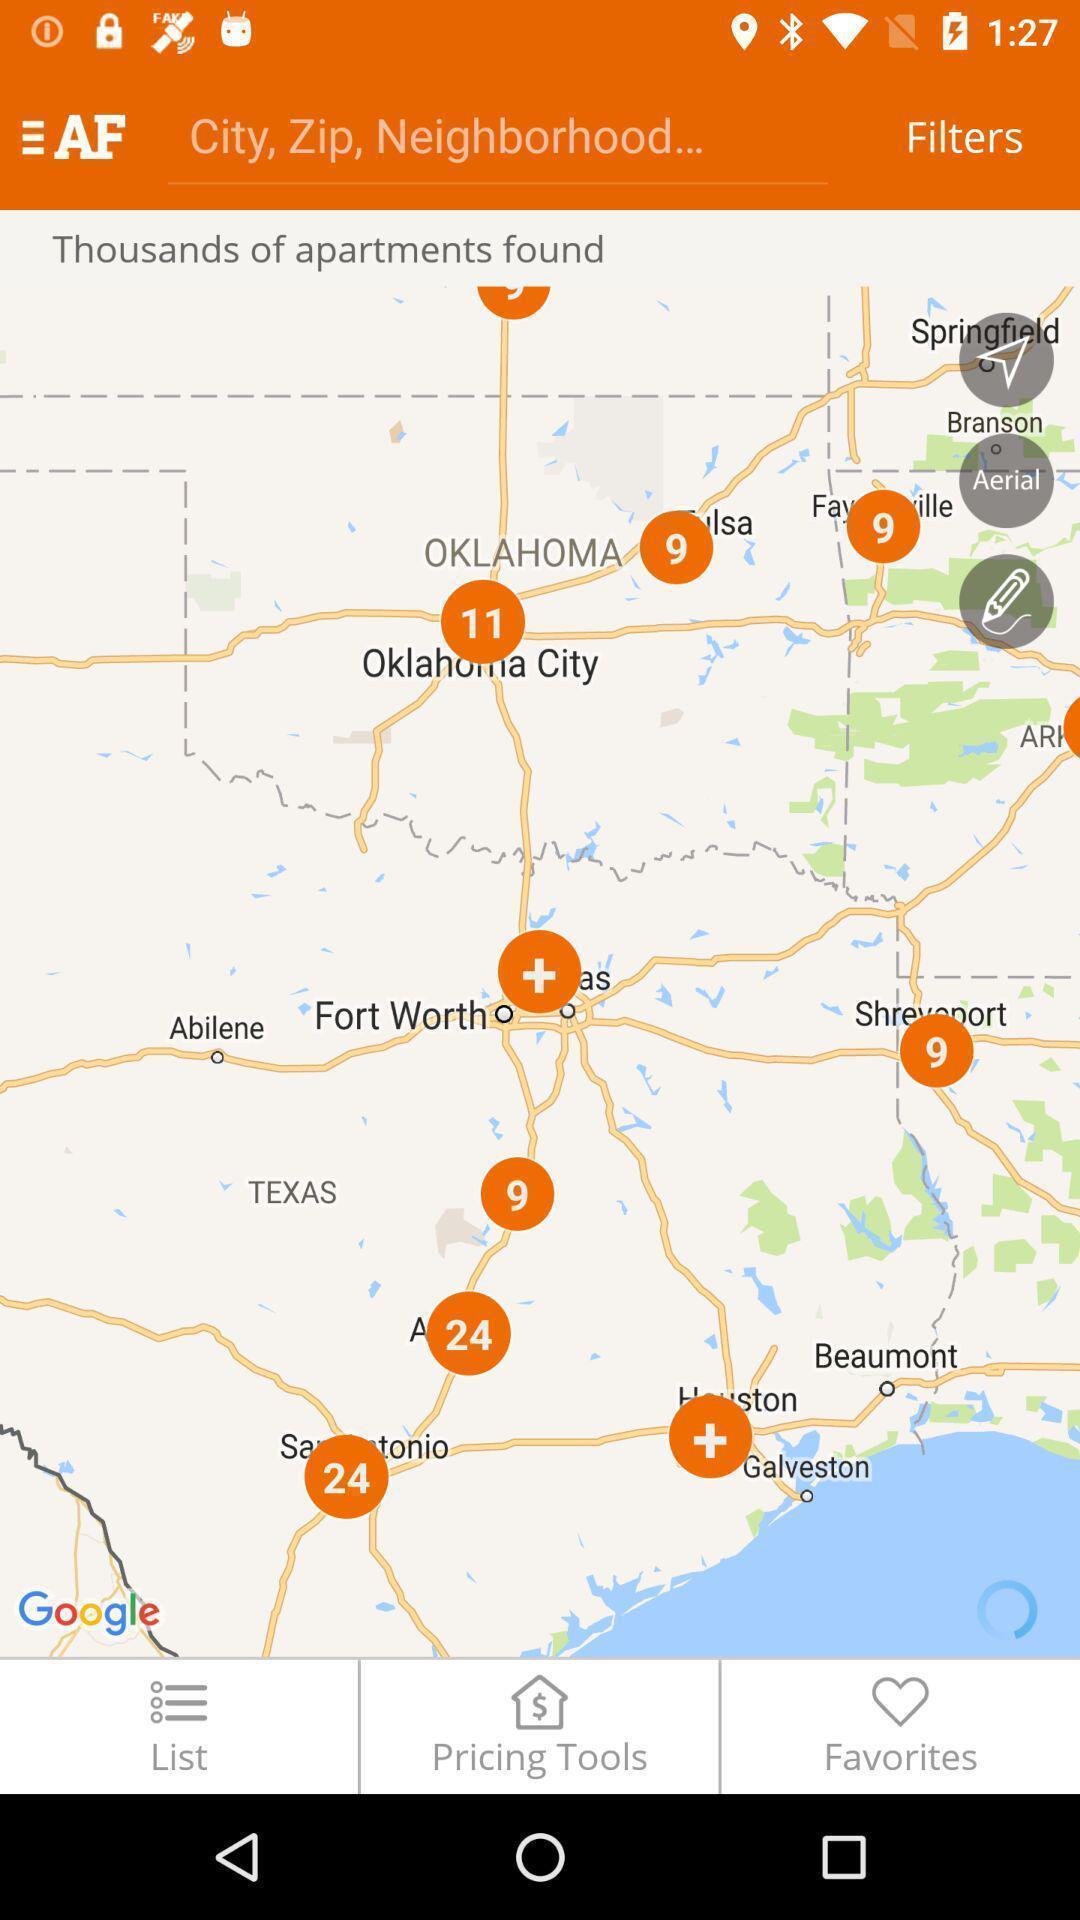Summarize the main components in this picture. Screen displaying search bar to find appartments. 